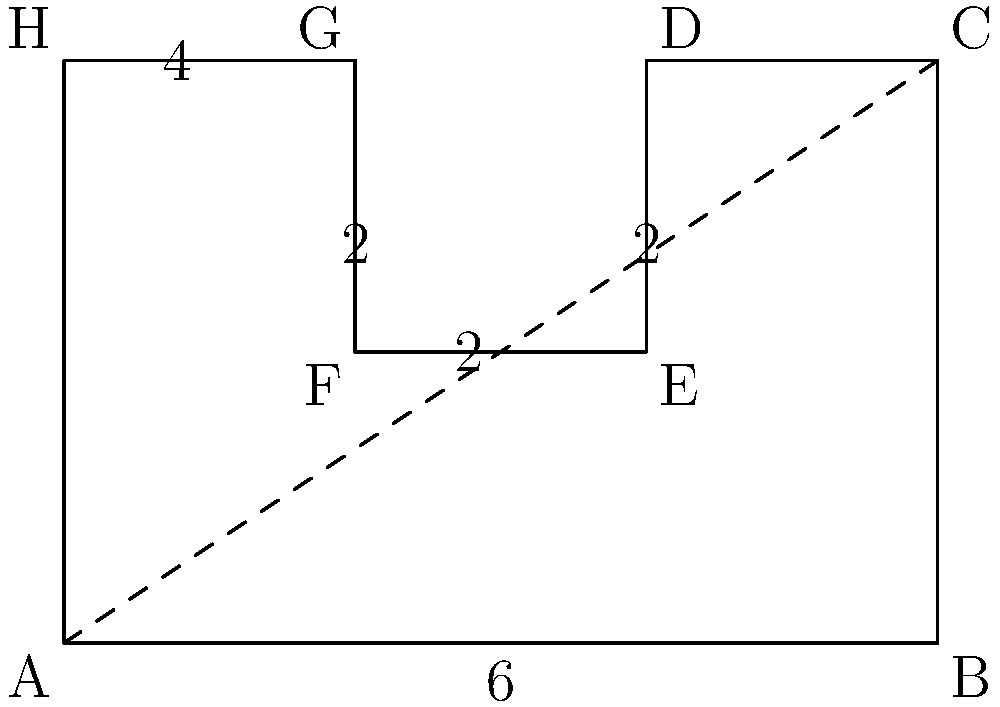A protected habitat for a rare species of bird has an irregular shape as shown in the diagram. The habitat is divided into rectangular sections. Calculate the total area of the habitat in square kilometers. To calculate the total area of the irregular shape, we can divide it into rectangles and sum their areas:

1. Divide the shape into three rectangles:
   - Rectangle 1: ABCH (bottom)
   - Rectangle 2: DEFG (top-right)
   - Rectangle 3: EFGH (top-left)

2. Calculate the area of each rectangle:
   - Area of Rectangle 1 (ABCH): 
     $A_1 = 6 \times 2 = 12$ sq km
   
   - Area of Rectangle 2 (DEFG):
     $A_2 = 2 \times 2 = 4$ sq km
   
   - Area of Rectangle 3 (EFGH):
     $A_3 = 2 \times 2 = 4$ sq km

3. Sum up the areas of all rectangles:
   $A_{total} = A_1 + A_2 + A_3 = 12 + 4 + 4 = 20$ sq km

Therefore, the total area of the habitat is 20 square kilometers.
Answer: 20 sq km 